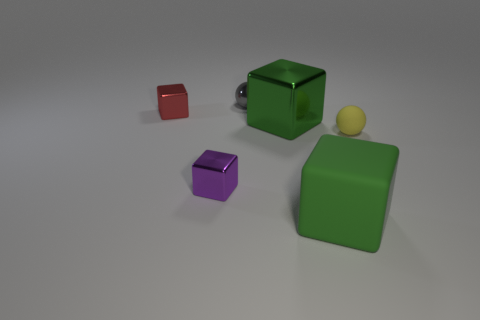Are there more big things than green metallic things?
Your response must be concise. Yes. What number of objects are either spheres that are in front of the small gray thing or metallic things?
Keep it short and to the point. 5. There is a small thing that is right of the metal sphere; what number of gray spheres are behind it?
Keep it short and to the point. 1. There is a sphere that is on the left side of the rubber object behind the small cube that is in front of the red metallic cube; how big is it?
Give a very brief answer. Small. Do the large metal block on the right side of the red object and the large matte object have the same color?
Provide a succinct answer. Yes. What is the size of the purple object that is the same shape as the red metal thing?
Offer a very short reply. Small. How many things are either tiny objects behind the small purple cube or metal things to the left of the big green shiny thing?
Offer a terse response. 4. The large object that is behind the small thing that is on the right side of the tiny gray ball is what shape?
Make the answer very short. Cube. Is there anything else of the same color as the rubber cube?
Offer a terse response. Yes. What number of things are small objects or tiny purple spheres?
Your response must be concise. 4. 